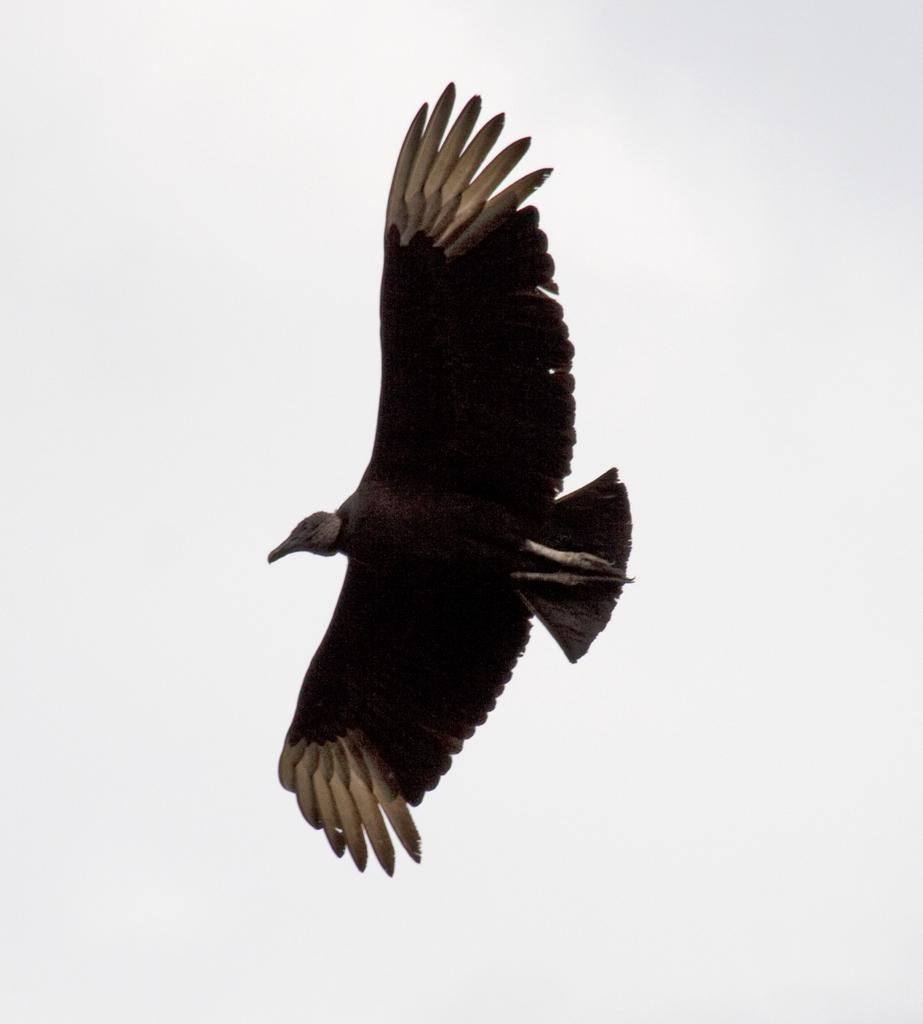What type of animal can be seen in the image? There is a bird in the image. What is the bird doing in the image? The bird is flying. What is the color of the background in the image? The background of the image is white. What type of crime is the bird committing in the image? There is no crime being committed in the image; it simply features a bird flying. How does the bird contribute to the harmony of the image? The bird's presence in the image does not inherently contribute to the harmony of the image, as harmony is a subjective concept. 